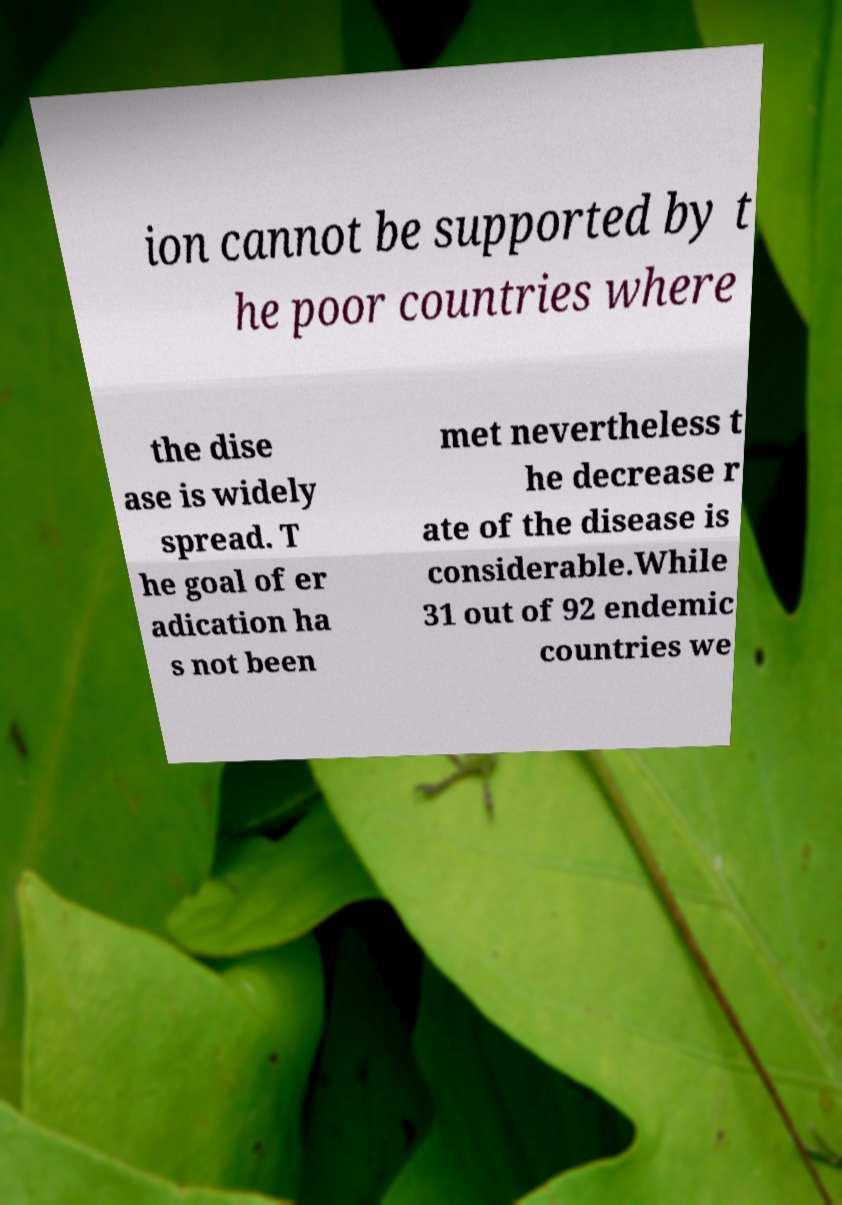Can you read and provide the text displayed in the image?This photo seems to have some interesting text. Can you extract and type it out for me? ion cannot be supported by t he poor countries where the dise ase is widely spread. T he goal of er adication ha s not been met nevertheless t he decrease r ate of the disease is considerable.While 31 out of 92 endemic countries we 